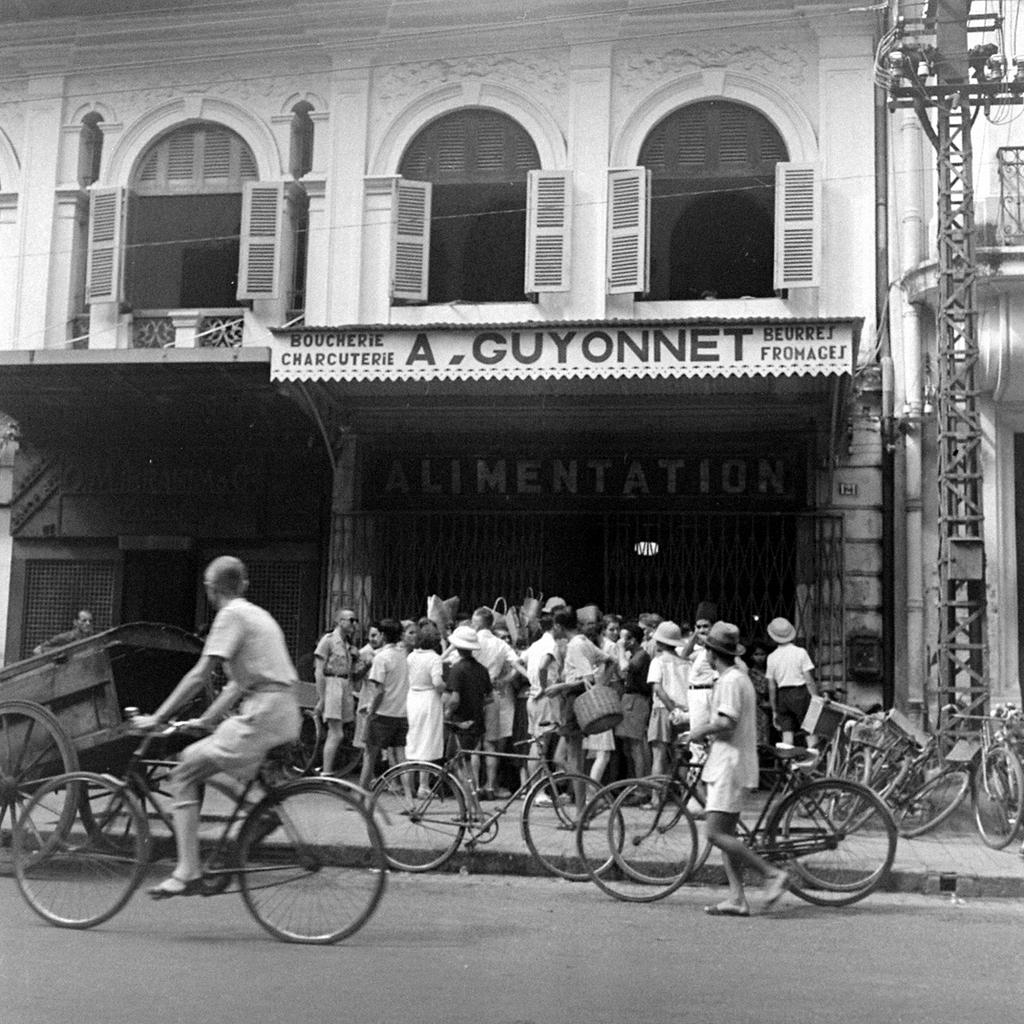What is the main subject of the image? There is a person riding a bicycle in the image. Where is the person riding the bicycle? The person is on the road. What can be seen in the background of the image? There are other bicycles, people, a building, and a railing in the background. What type of caption is written on the bicycle in the image? There is no caption written on the bicycle in the image. How is the person riding the bicycle using the pump in the image? There is no pump present in the image; the person is simply riding a bicycle. 